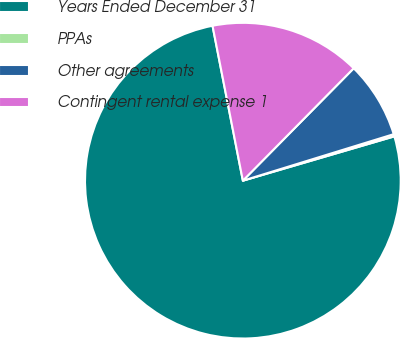Convert chart. <chart><loc_0><loc_0><loc_500><loc_500><pie_chart><fcel>Years Ended December 31<fcel>PPAs<fcel>Other agreements<fcel>Contingent rental expense 1<nl><fcel>76.45%<fcel>0.23%<fcel>7.85%<fcel>15.47%<nl></chart> 